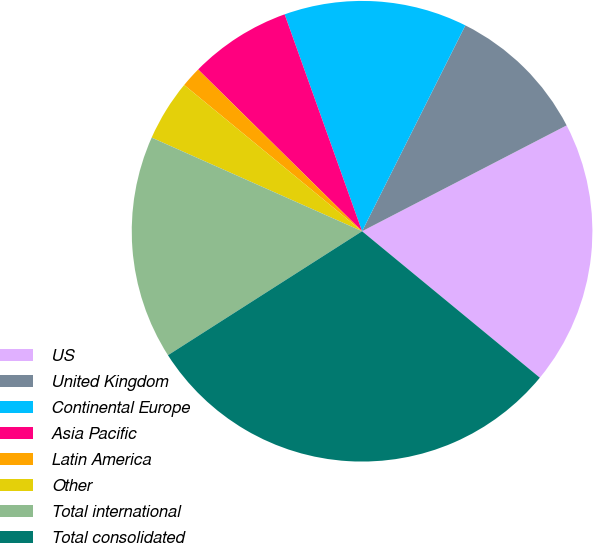<chart> <loc_0><loc_0><loc_500><loc_500><pie_chart><fcel>US<fcel>United Kingdom<fcel>Continental Europe<fcel>Asia Pacific<fcel>Latin America<fcel>Other<fcel>Total international<fcel>Total consolidated<nl><fcel>18.57%<fcel>10.0%<fcel>12.86%<fcel>7.15%<fcel>1.44%<fcel>4.29%<fcel>15.71%<fcel>29.99%<nl></chart> 